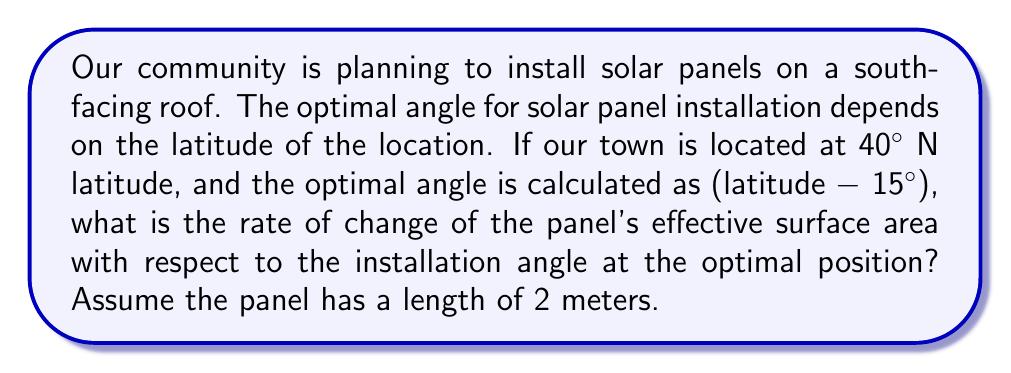Teach me how to tackle this problem. Let's approach this step-by-step:

1) First, let's calculate the optimal angle:
   Optimal angle = Latitude - 15°
   $$ \theta_{opt} = 40° - 15° = 25° $$

2) The effective surface area of a solar panel is given by:
   $$ A = L \sin(\theta) $$
   where $A$ is the effective area, $L$ is the length of the panel, and $\theta$ is the angle of installation.

3) To find the rate of change of the effective surface area with respect to the angle, we need to differentiate $A$ with respect to $\theta$:
   $$ \frac{dA}{d\theta} = L \cos(\theta) $$

4) Now, we need to evaluate this at the optimal angle $\theta_{opt} = 25°$:
   $$ \left.\frac{dA}{d\theta}\right|_{\theta=25°} = L \cos(25°) $$

5) Given that $L = 2$ meters, we can substitute this value:
   $$ \left.\frac{dA}{d\theta}\right|_{\theta=25°} = 2 \cos(25°) $$

6) Calculate the final result:
   $$ \left.\frac{dA}{d\theta}\right|_{\theta=25°} = 2 \cdot 0.9063 = 1.8126 \text{ m} $$

This means that at the optimal angle, a small change in the angle will result in a change of about 1.8126 m in the effective surface area per radian of angle change.
Answer: $1.8126 \text{ m}$ 